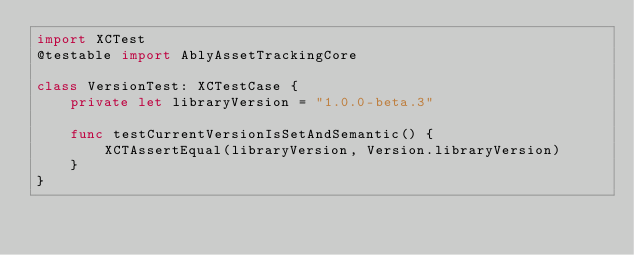Convert code to text. <code><loc_0><loc_0><loc_500><loc_500><_Swift_>import XCTest
@testable import AblyAssetTrackingCore

class VersionTest: XCTestCase {
    private let libraryVersion = "1.0.0-beta.3"
    
    func testCurrentVersionIsSetAndSemantic() {
        XCTAssertEqual(libraryVersion, Version.libraryVersion)
    }
}
</code> 